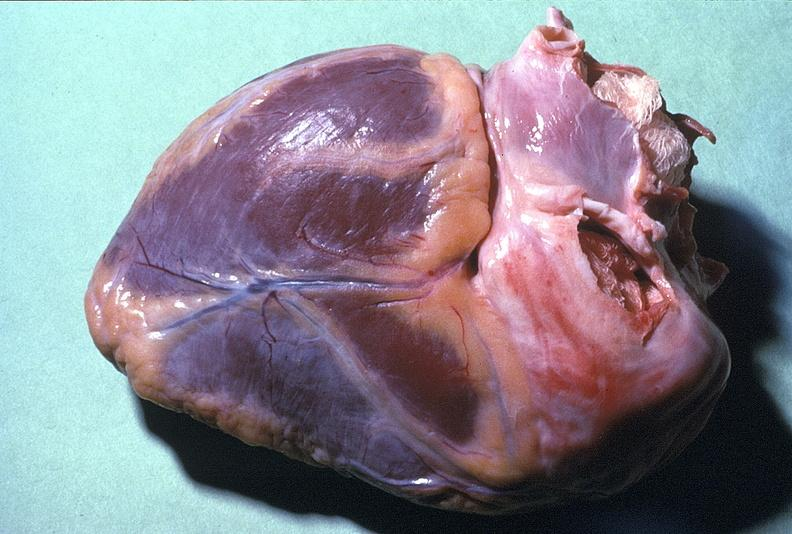what is present?
Answer the question using a single word or phrase. Cardiovascular 